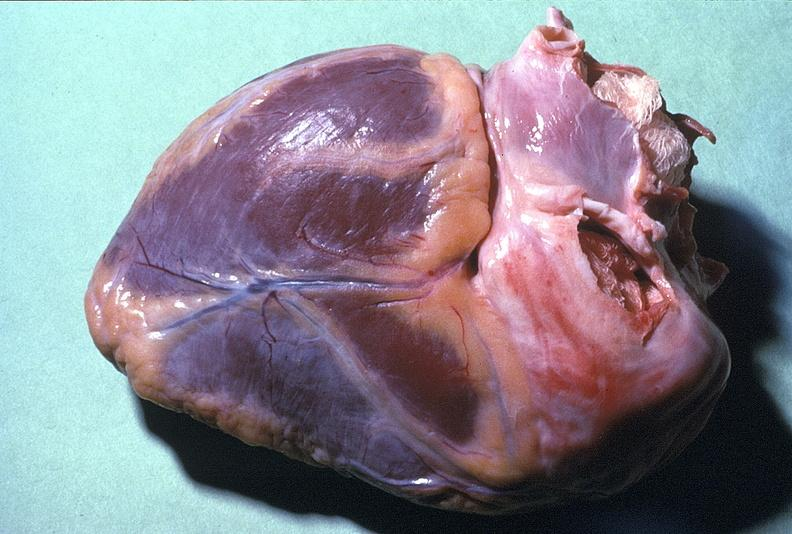what is present?
Answer the question using a single word or phrase. Cardiovascular 